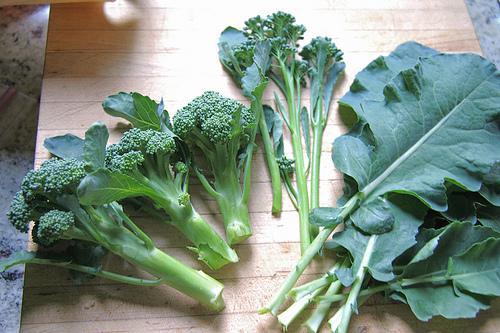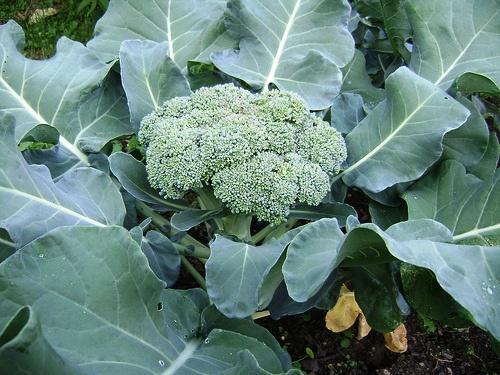The first image is the image on the left, the second image is the image on the right. Evaluate the accuracy of this statement regarding the images: "An image shows broccoli growing in soil, with leaves surrounding the florets.". Is it true? Answer yes or no. Yes. The first image is the image on the left, the second image is the image on the right. Analyze the images presented: Is the assertion "Broccoli is shown in both images, but in one it is a plant in the garden and in the other, it is cleaned for eating or cooking." valid? Answer yes or no. Yes. 